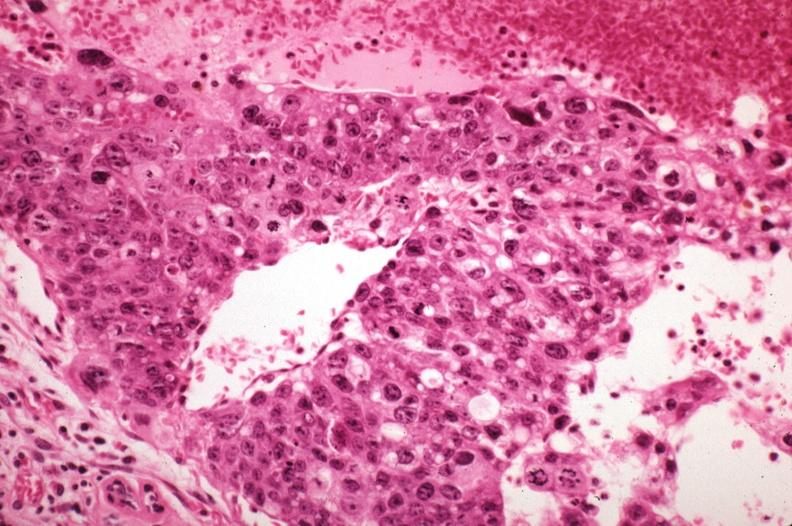what sickled red cells in vessels well shown?
Answer the question using a single word or phrase. Metastatic choriocarcinoma with pleomorphism and mitotic figures 